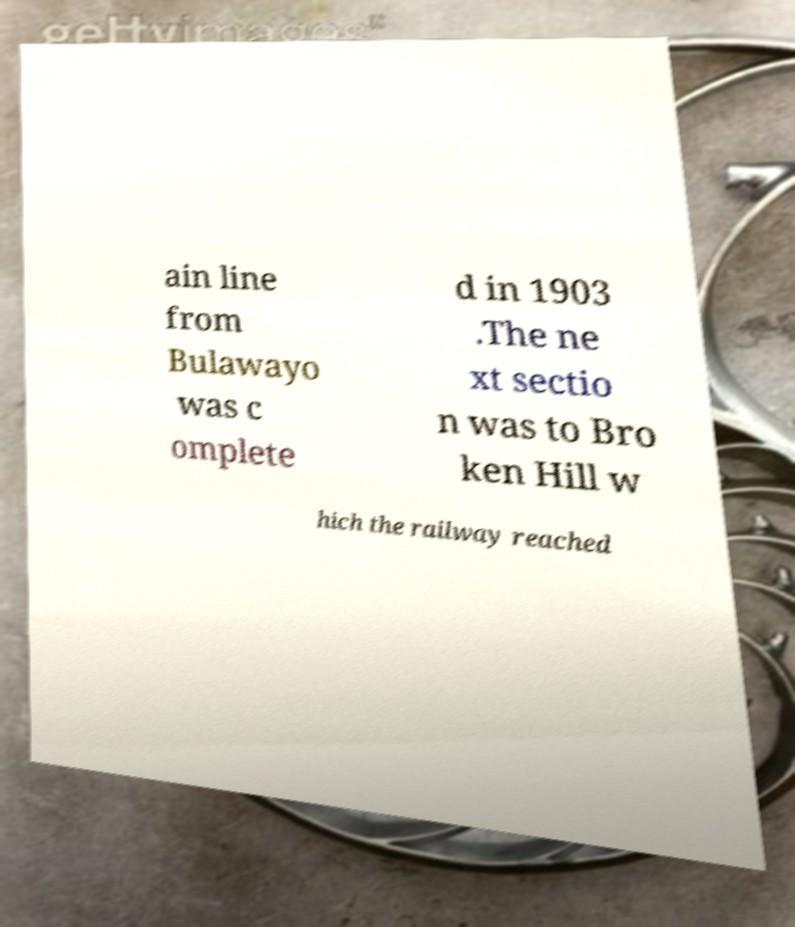Please identify and transcribe the text found in this image. ain line from Bulawayo was c omplete d in 1903 .The ne xt sectio n was to Bro ken Hill w hich the railway reached 